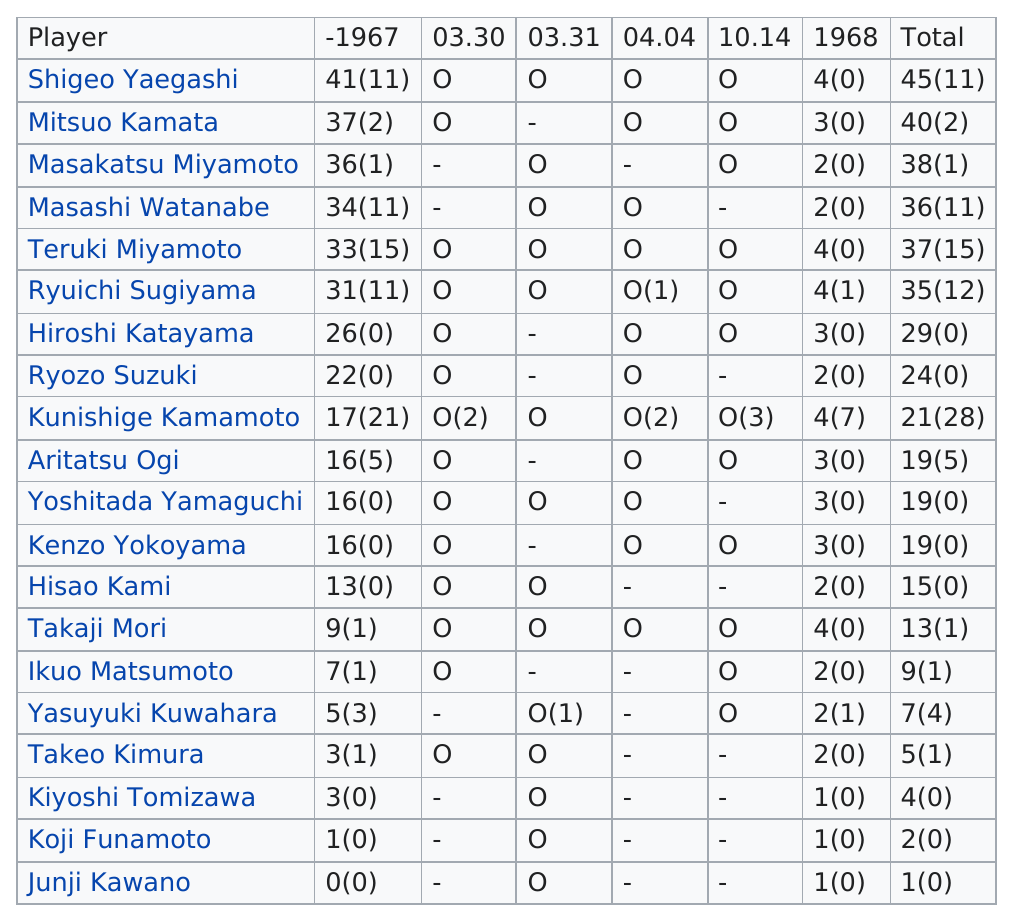Highlight a few significant elements in this photo. Takaji Mori had more points than Junji Kawano. Mitsuo Kamata had a total of 40(2). Mitsuo Kamata did not have more than 40 total points. The total number of appearances by Masakatsu Miyamoto is 38. In that year, 20 players made an appearance. 